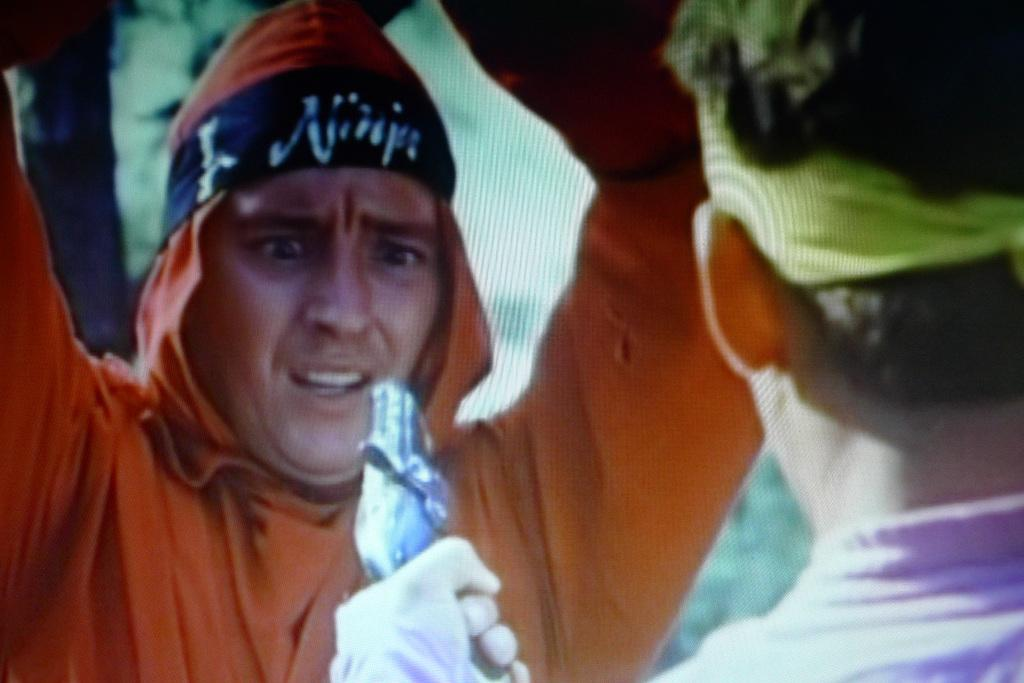How many people are in the image? There are two persons in the image. What is one of the persons holding? One of the persons is holding a gun. What type of example can be seen in the image? There is no example present in the image; it features two persons, one of whom is holding a gun. Can you tell me how many clams are visible in the image? There are no clams present in the image. 